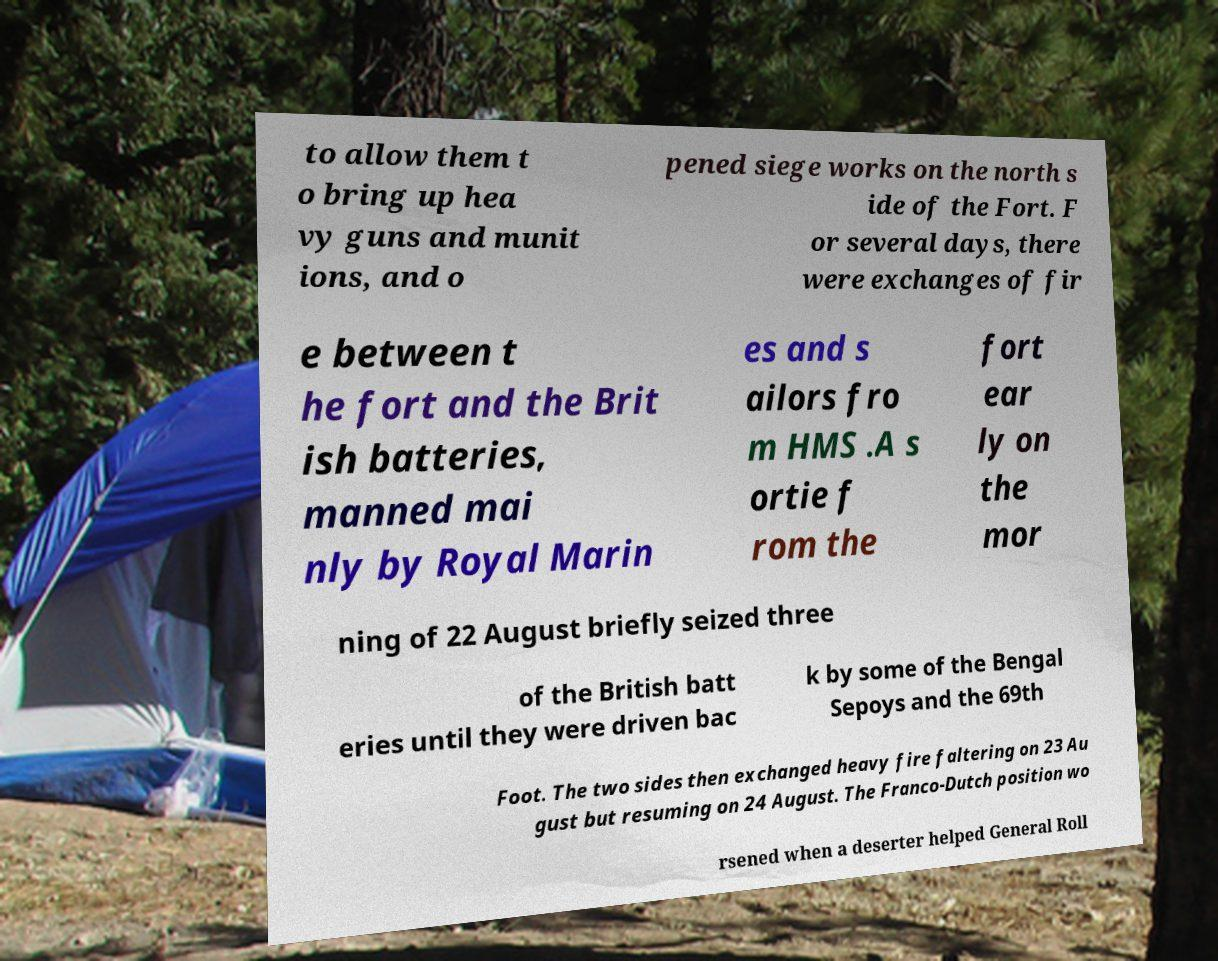I need the written content from this picture converted into text. Can you do that? to allow them t o bring up hea vy guns and munit ions, and o pened siege works on the north s ide of the Fort. F or several days, there were exchanges of fir e between t he fort and the Brit ish batteries, manned mai nly by Royal Marin es and s ailors fro m HMS .A s ortie f rom the fort ear ly on the mor ning of 22 August briefly seized three of the British batt eries until they were driven bac k by some of the Bengal Sepoys and the 69th Foot. The two sides then exchanged heavy fire faltering on 23 Au gust but resuming on 24 August. The Franco-Dutch position wo rsened when a deserter helped General Roll 